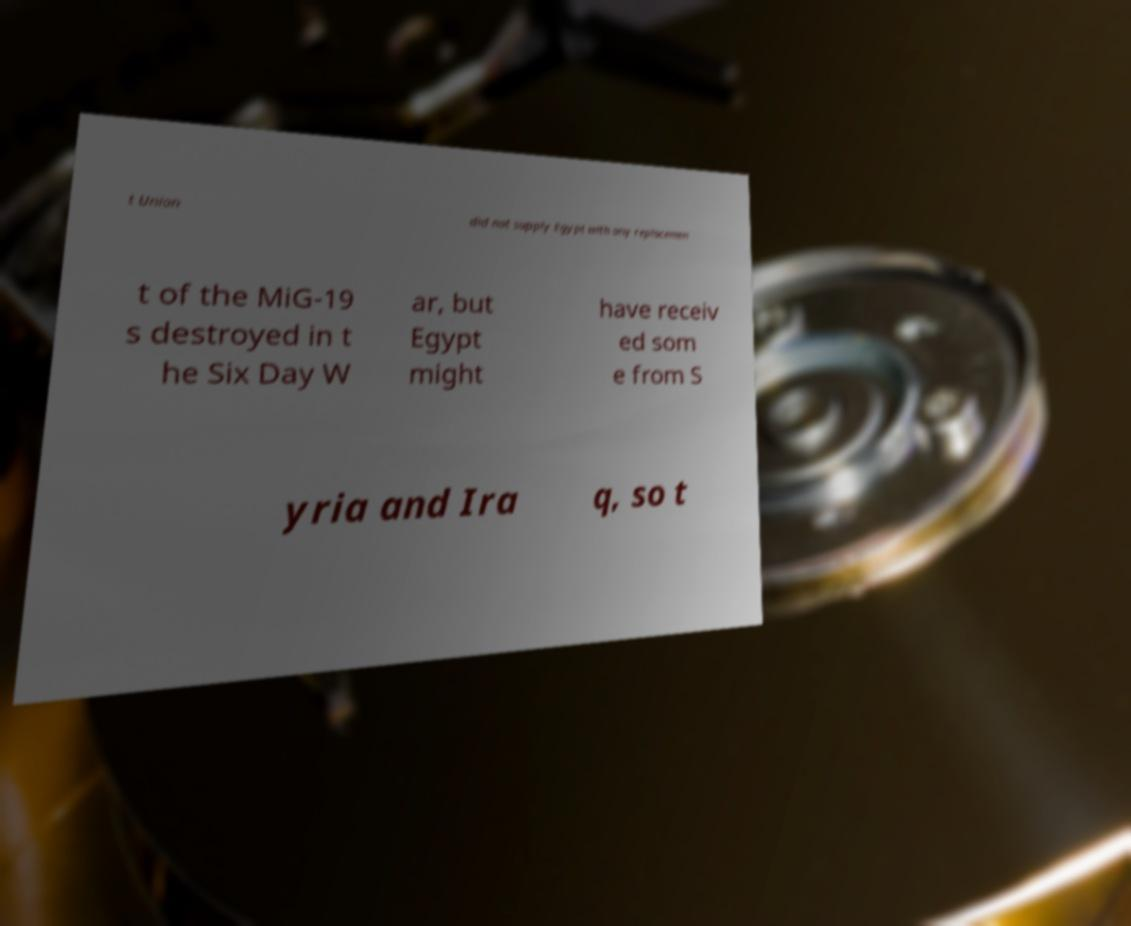Can you read and provide the text displayed in the image?This photo seems to have some interesting text. Can you extract and type it out for me? t Union did not supply Egypt with any replacemen t of the MiG-19 s destroyed in t he Six Day W ar, but Egypt might have receiv ed som e from S yria and Ira q, so t 